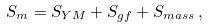<formula> <loc_0><loc_0><loc_500><loc_500>S _ { m } = S _ { Y M } + S _ { g f } + S _ { m a s s } \, ,</formula> 